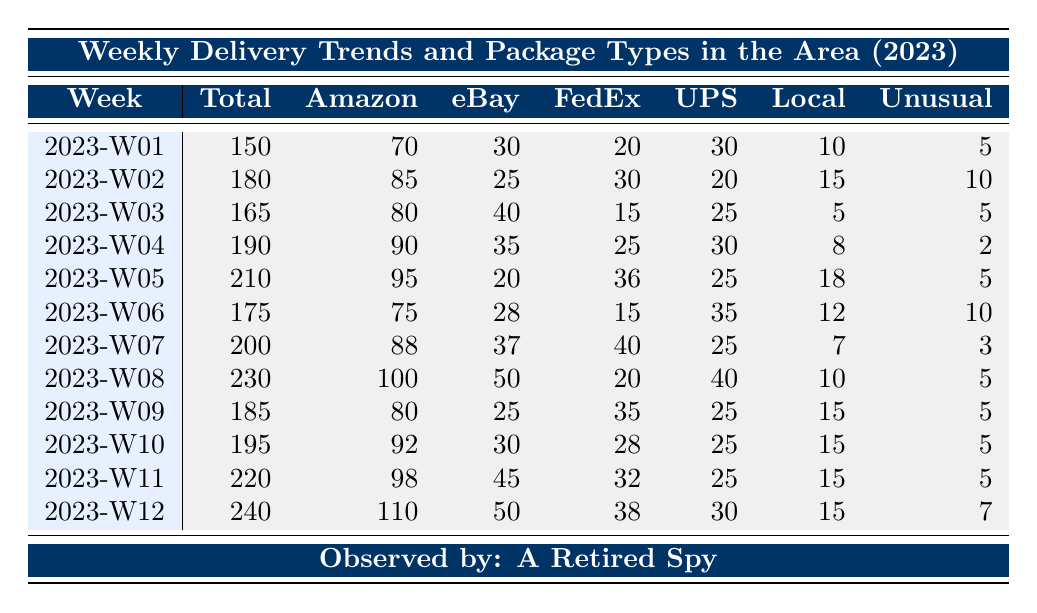What was the total number of packages delivered in week 5? The table shows that in week 5 (2023-W05), the total number of packages delivered is listed directly as 210.
Answer: 210 How many Amazon packages were delivered in week 2? In week 2 (2023-W02), the table indicates that there were 85 Amazon packages delivered.
Answer: 85 What is the week with the highest number of unusual packages delivered? By examining the 'UnusualPackages' column, the highest number was 10, which occurred in both week 2 and week 6. The week number does not just occur once.
Answer: Week 2 and Week 6 What is the average number of packages delivered per week for the first quarter (weeks 1 to 12)? To find the average, sum the total packages delivered from weeks 1 to 12 (150 + 180 + 165 + 190 + 210 + 175 + 200 + 230 + 185 + 195 + 220 + 240 = 2,375) and divide by 12, which gives 2,375 / 12 = 197.92, rounding down gives 197.
Answer: 197 Was the number of UPS deliveries higher in week 8 than in week 7? In week 8 (2023-W08), UPS delivered 40 packages, while in week 7 (2023-W07), they delivered only 25 packages. Since 40 is greater than 25, the answer is yes.
Answer: Yes What was the total number of Federal Express deliveries in the first quarter? Adding the numbers from the 'FedExDeliveries' for each week gives: 20 + 30 + 15 + 25 + 36 + 15 + 40 + 20 + 35 + 28 + 32 + 38 =  380 deliveries in total.
Answer: 380 Which week had more eBay packages, week 3 or week 5? Week 3 (2023-W03) had 40 eBay packages and week 5 (2023-W05) had 20 eBay packages. Since 40 > 20, week 3 had more.
Answer: Week 3 Calculate the difference in total packages delivered between week 12 and week 1. Week 12 delivered 240 packages, while week 1 delivered 150. The difference is 240 - 150 = 90.
Answer: 90 Which week had the most Amazon packages delivered? The table shows that week 12 had the highest number of Amazon packages delivered, at 110.
Answer: Week 12 Is the total number of deliveries for week 11 greater than the total for week 9? The total for week 11 is 220 and for week 9 it is 185. Since 220 is greater than 185, the answer is yes.
Answer: Yes What is the median number of local business deliveries for weeks 1 through 12? The local delivery values are: 10, 15, 5, 8, 18, 12, 7, 10, 15, 15, 15, 15. When sorted: 5, 7, 8, 10, 10, 12, 15, 15, 15, 15, 15, 18. The median is the average of the 6th and 7th sorted values (12 + 15) / 2 = 13.5.
Answer: 13.5 